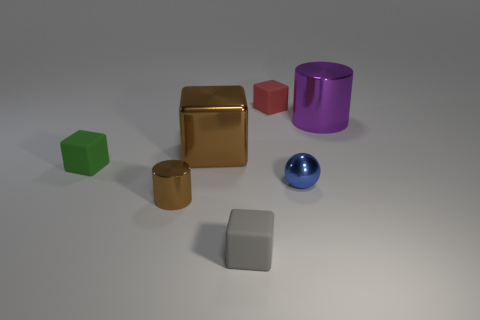Is the shape of the large metallic object on the right side of the tiny red rubber cube the same as  the small gray matte object?
Your answer should be compact. No. Are there fewer gray matte objects in front of the gray thing than purple things that are in front of the tiny green rubber block?
Provide a short and direct response. No. There is a cylinder in front of the purple object; what material is it?
Ensure brevity in your answer.  Metal. There is a metal cube that is the same color as the tiny cylinder; what is its size?
Your answer should be very brief. Large. Are there any other purple metallic things of the same size as the purple thing?
Your answer should be very brief. No. Do the tiny blue object and the big object that is to the right of the red object have the same shape?
Make the answer very short. No. There is a brown metallic object that is on the left side of the large brown metallic cube; does it have the same size as the cube behind the purple object?
Provide a succinct answer. Yes. How many other things are there of the same shape as the tiny gray rubber thing?
Keep it short and to the point. 3. What is the material of the cylinder that is left of the matte thing behind the green matte block?
Make the answer very short. Metal. What number of rubber objects are either tiny purple blocks or red objects?
Your answer should be very brief. 1. 